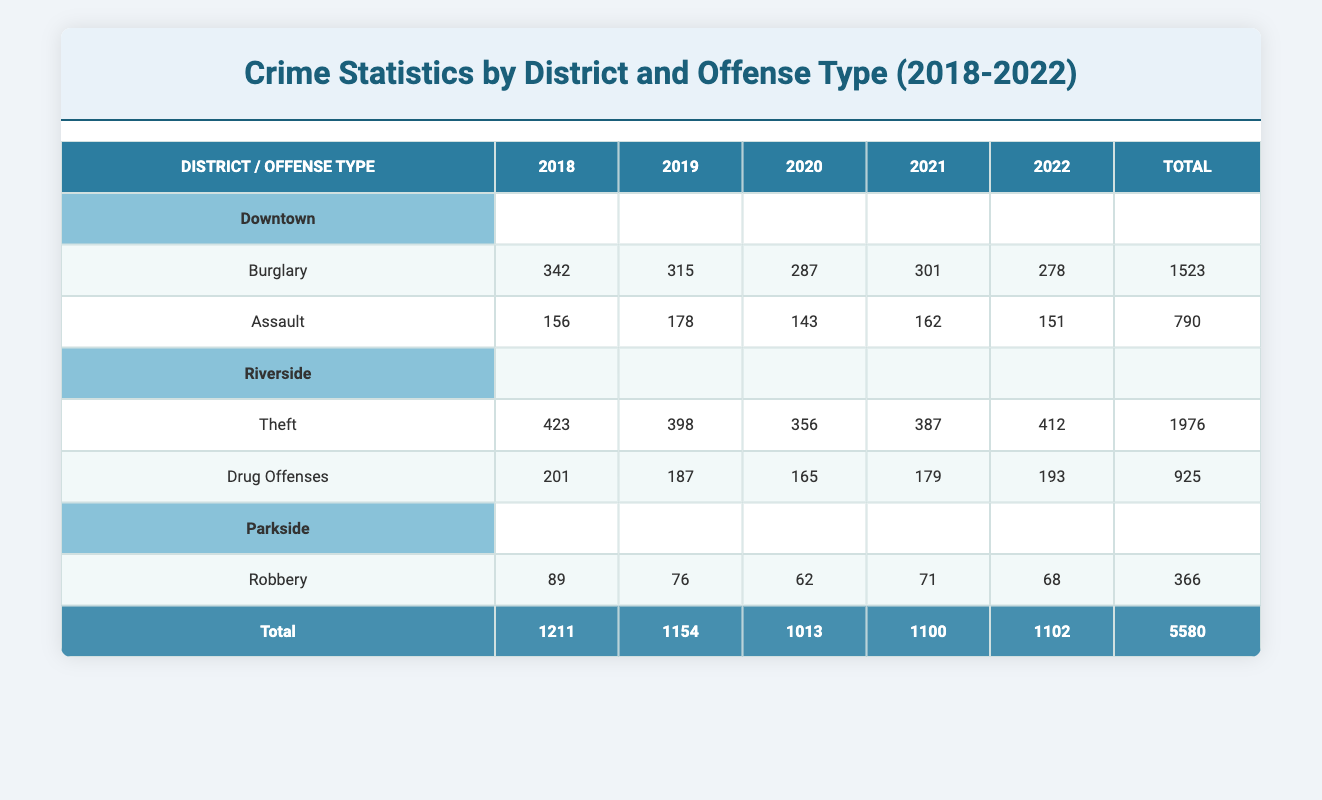What was the total number of burglaries in Downtown from 2018 to 2022? To find the total number of burglaries in Downtown, we need to add the burglary counts for each year: 342 (2018) + 315 (2019) + 287 (2020) + 301 (2021) + 278 (2022) = 1523.
Answer: 1523 Which district had the highest number of thefts in 2022? Looking at the column for 2022, Riverside reported 412 thefts, while Downtown and Parkside did not list thefts. Thus, Riverside had the highest number of thefts.
Answer: Riverside Is the total number of drug offenses in Riverside higher than or equal to that in Downtown for all years? We compare the total drug offense counts for both districts: Riverside has 925 (2018-2022) while Downtown has no drug offenses listed. Therefore, Riverside has more drug offenses.
Answer: No What is the average number of robberies in Parkside from 2018 to 2022? To find the average number of robberies in Parkside, we sum the robbery counts: 89 (2018) + 76 (2019) + 62 (2020) + 71 (2021) + 68 (2022) = 366. Then we divide by the number of years (5): 366 / 5 = 73.2.
Answer: 73.2 In which year did Downtown experience the highest number of assaults? The counts of assaults in Downtown are: 156 (2018), 178 (2019), 143 (2020), 162 (2021), 151 (2022). The highest count is 178 in 2019.
Answer: 2019 What is the total number of offenses recorded in 2021 across all districts? To find this, we sum the counts for 2021: Downtown has 301 (Burglary) + 162 (Assault) = 463; Riverside has 387 (Theft) + 179 (Drug Offenses) = 566; Parkside has 71 (Robbery). The total is 463 + 566 + 71 = 1100.
Answer: 1100 Did the number of burglaries in Downtown decrease in 2020 compared to 2019? From the data, Downtown had 315 burglaries in 2019 and 287 in 2020. Since 287 is less than 315, this indicates a decrease.
Answer: Yes Which offense type had the lowest total count across all years in Parkside? The only offense type in the Parkside district is Robbery, which has a total of 366 over the years. Thus, it is the lowest as it is the only category present.
Answer: Robbery 